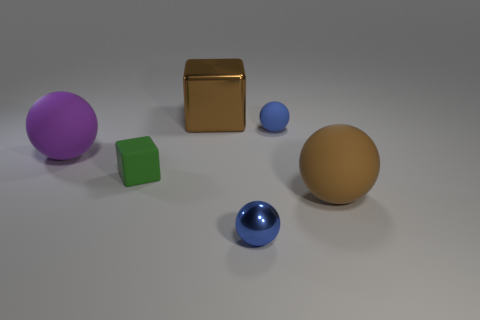Add 2 shiny spheres. How many objects exist? 8 Subtract all cubes. How many objects are left? 4 Subtract all yellow matte things. Subtract all purple balls. How many objects are left? 5 Add 4 tiny spheres. How many tiny spheres are left? 6 Add 5 cyan rubber blocks. How many cyan rubber blocks exist? 5 Subtract 0 cyan spheres. How many objects are left? 6 